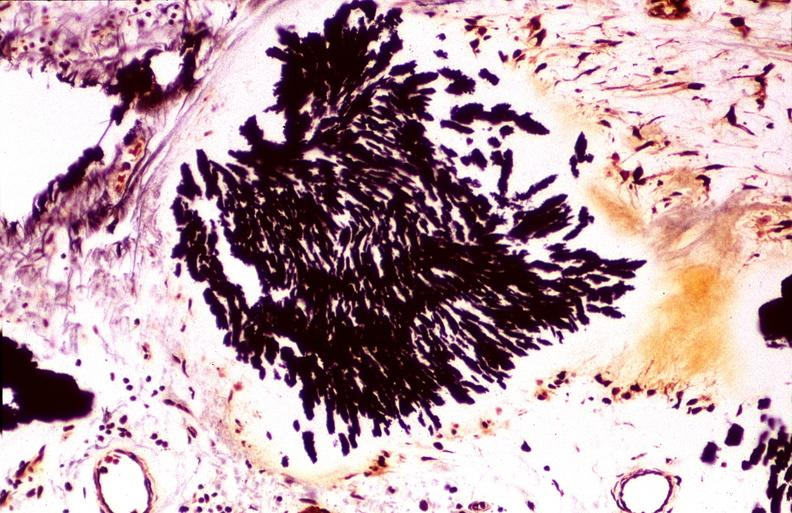does endometritis postpartum show gout, alcohol fixed tissues, monosodium urate crystals?
Answer the question using a single word or phrase. No 